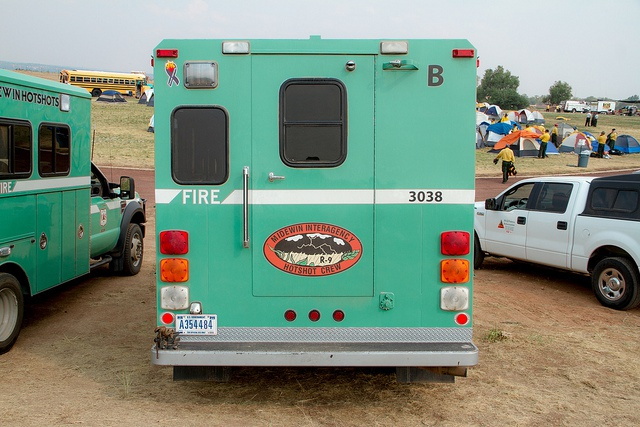Describe the objects in this image and their specific colors. I can see truck in lightgray, turquoise, darkgray, and black tones, bus in lightgray, turquoise, darkgray, black, and gray tones, truck in lightgray, black, teal, and gray tones, car in lightgray, black, darkgray, lightblue, and gray tones, and truck in lightgray, black, darkgray, lightblue, and gray tones in this image. 